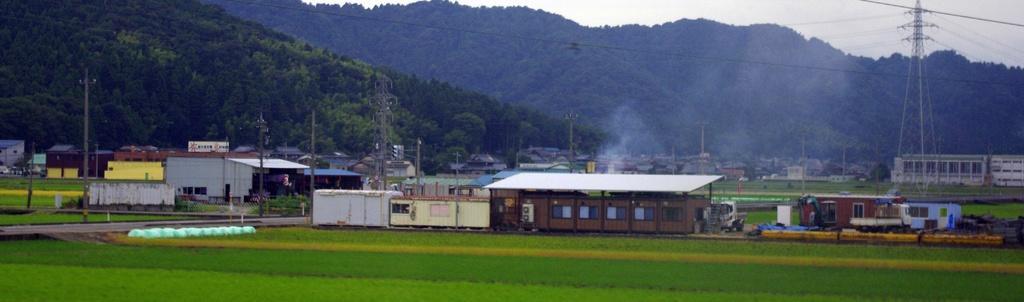Can you describe this image briefly? In this picture I can see there are fields and there are few buildings and there are electric towers with cables attached and in the backdrop there are mountains they are covered with trees and the sky is clear. 